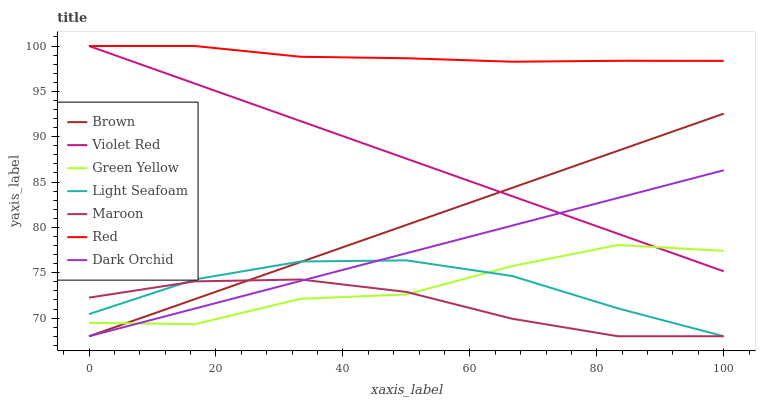Does Maroon have the minimum area under the curve?
Answer yes or no. Yes. Does Red have the maximum area under the curve?
Answer yes or no. Yes. Does Violet Red have the minimum area under the curve?
Answer yes or no. No. Does Violet Red have the maximum area under the curve?
Answer yes or no. No. Is Violet Red the smoothest?
Answer yes or no. Yes. Is Green Yellow the roughest?
Answer yes or no. Yes. Is Light Seafoam the smoothest?
Answer yes or no. No. Is Light Seafoam the roughest?
Answer yes or no. No. Does Violet Red have the lowest value?
Answer yes or no. No. Does Red have the highest value?
Answer yes or no. Yes. Does Light Seafoam have the highest value?
Answer yes or no. No. Is Brown less than Red?
Answer yes or no. Yes. Is Red greater than Light Seafoam?
Answer yes or no. Yes. Does Brown intersect Dark Orchid?
Answer yes or no. Yes. Is Brown less than Dark Orchid?
Answer yes or no. No. Is Brown greater than Dark Orchid?
Answer yes or no. No. Does Brown intersect Red?
Answer yes or no. No. 